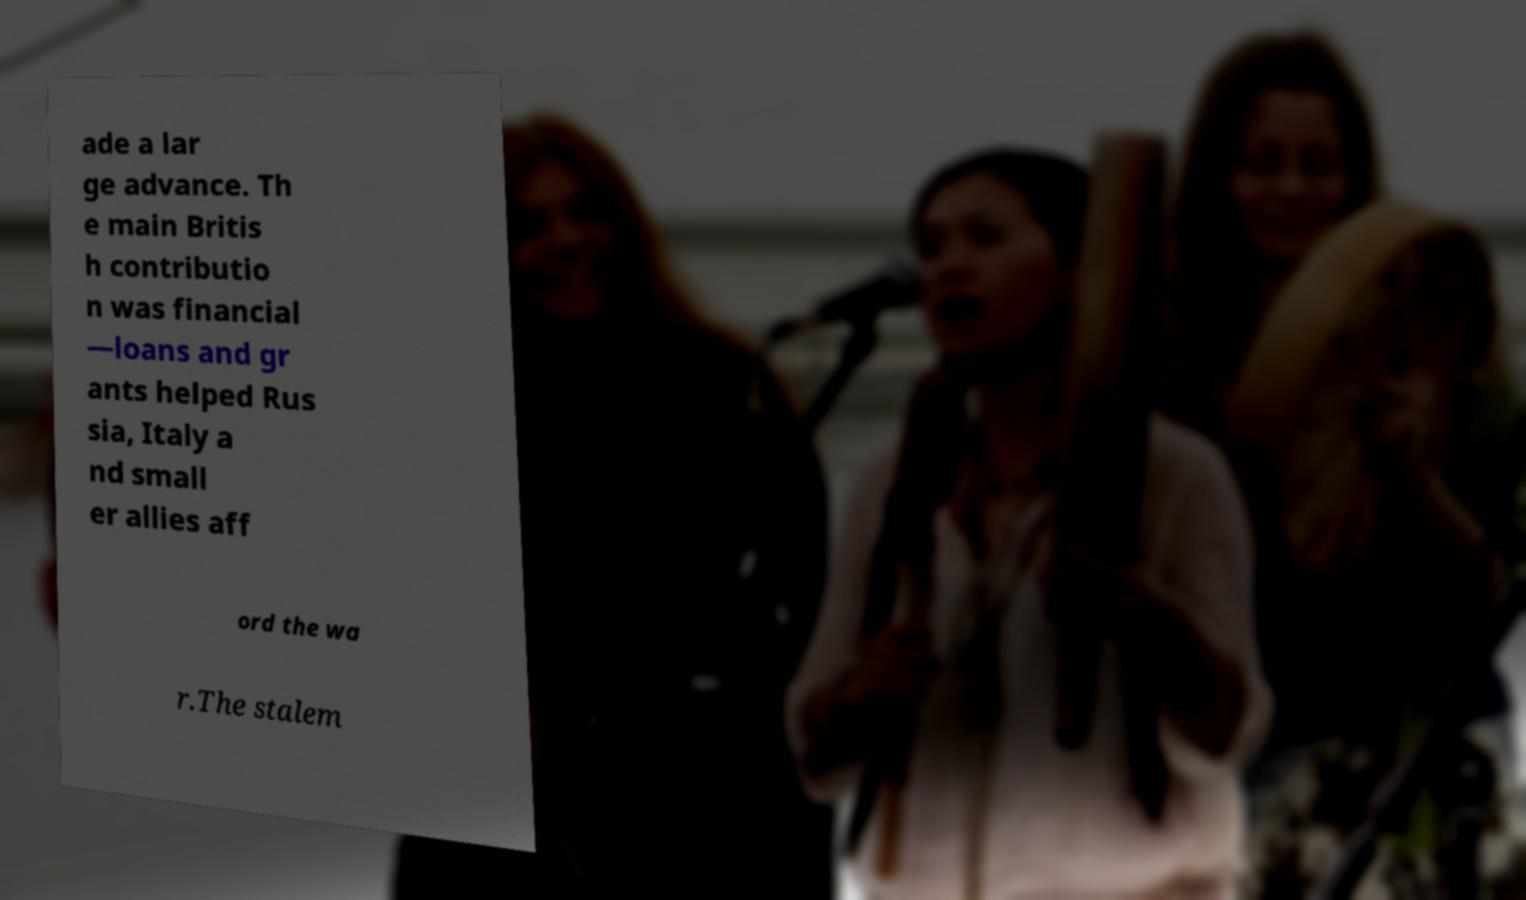Please read and relay the text visible in this image. What does it say? ade a lar ge advance. Th e main Britis h contributio n was financial —loans and gr ants helped Rus sia, Italy a nd small er allies aff ord the wa r.The stalem 